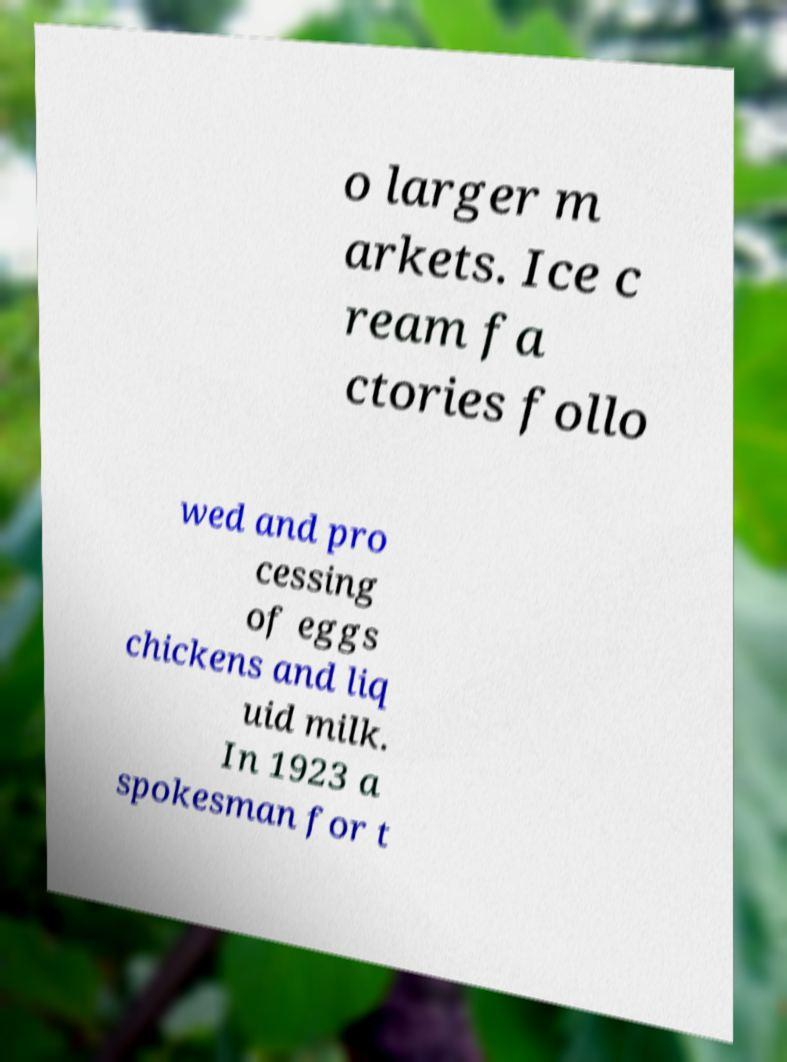For documentation purposes, I need the text within this image transcribed. Could you provide that? o larger m arkets. Ice c ream fa ctories follo wed and pro cessing of eggs chickens and liq uid milk. In 1923 a spokesman for t 